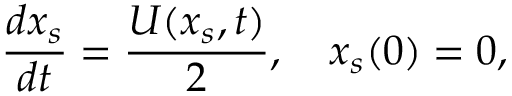<formula> <loc_0><loc_0><loc_500><loc_500>\frac { d x _ { s } } { d t } = \frac { U ( x _ { s } , t ) } { 2 } , \quad x _ { s } ( 0 ) = 0 ,</formula> 